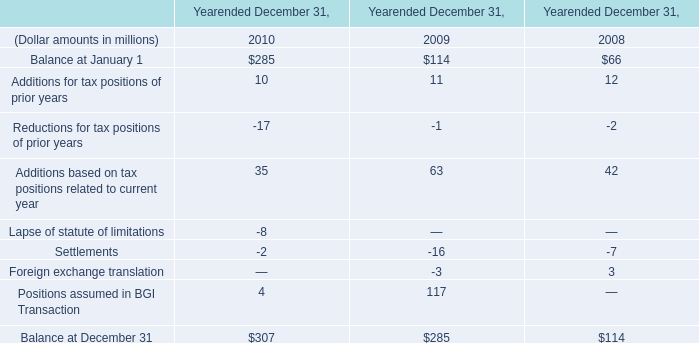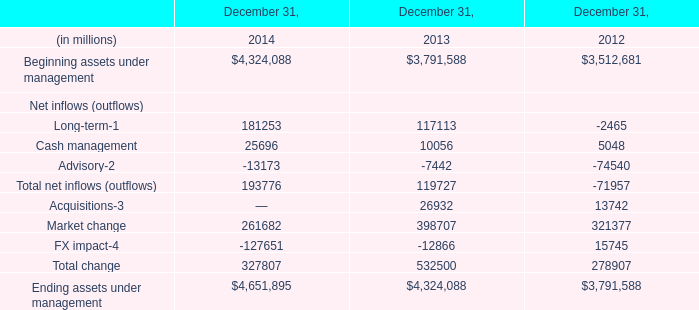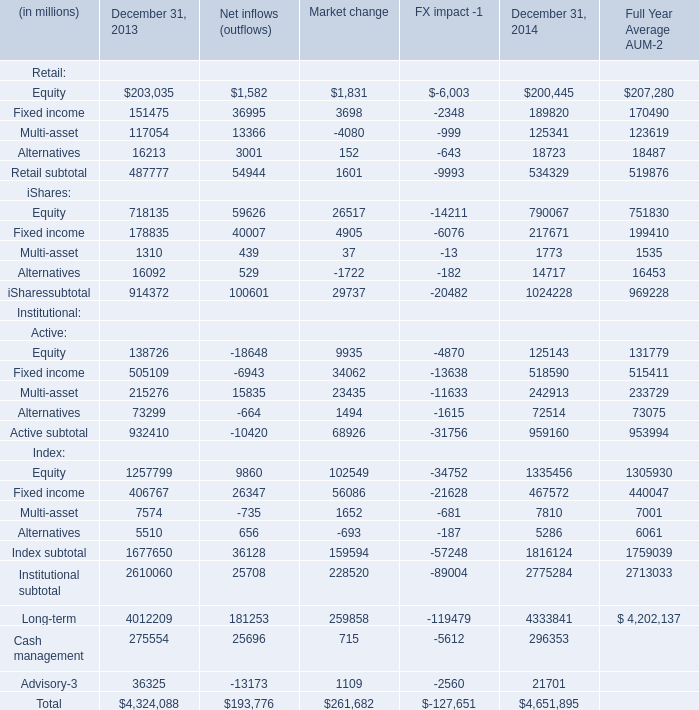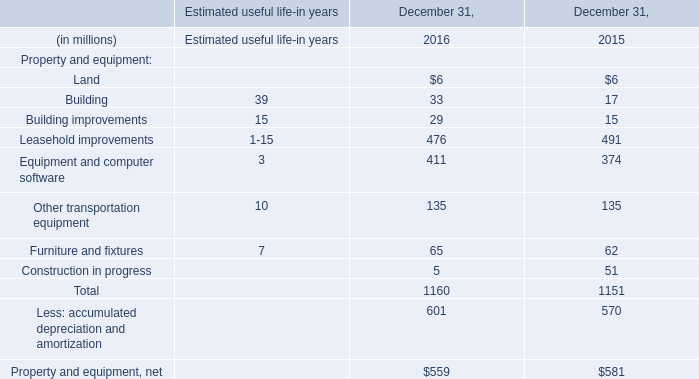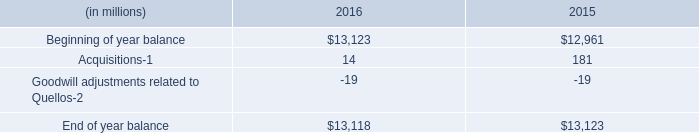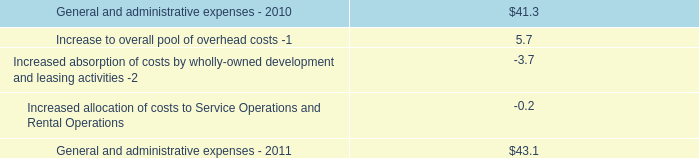What's the average of Beginning assets under management in 2012,2013, and 2014? (in million) 
Computations: (((4324088 + 3791588) + 3512681) / 3)
Answer: 3876119.0. 